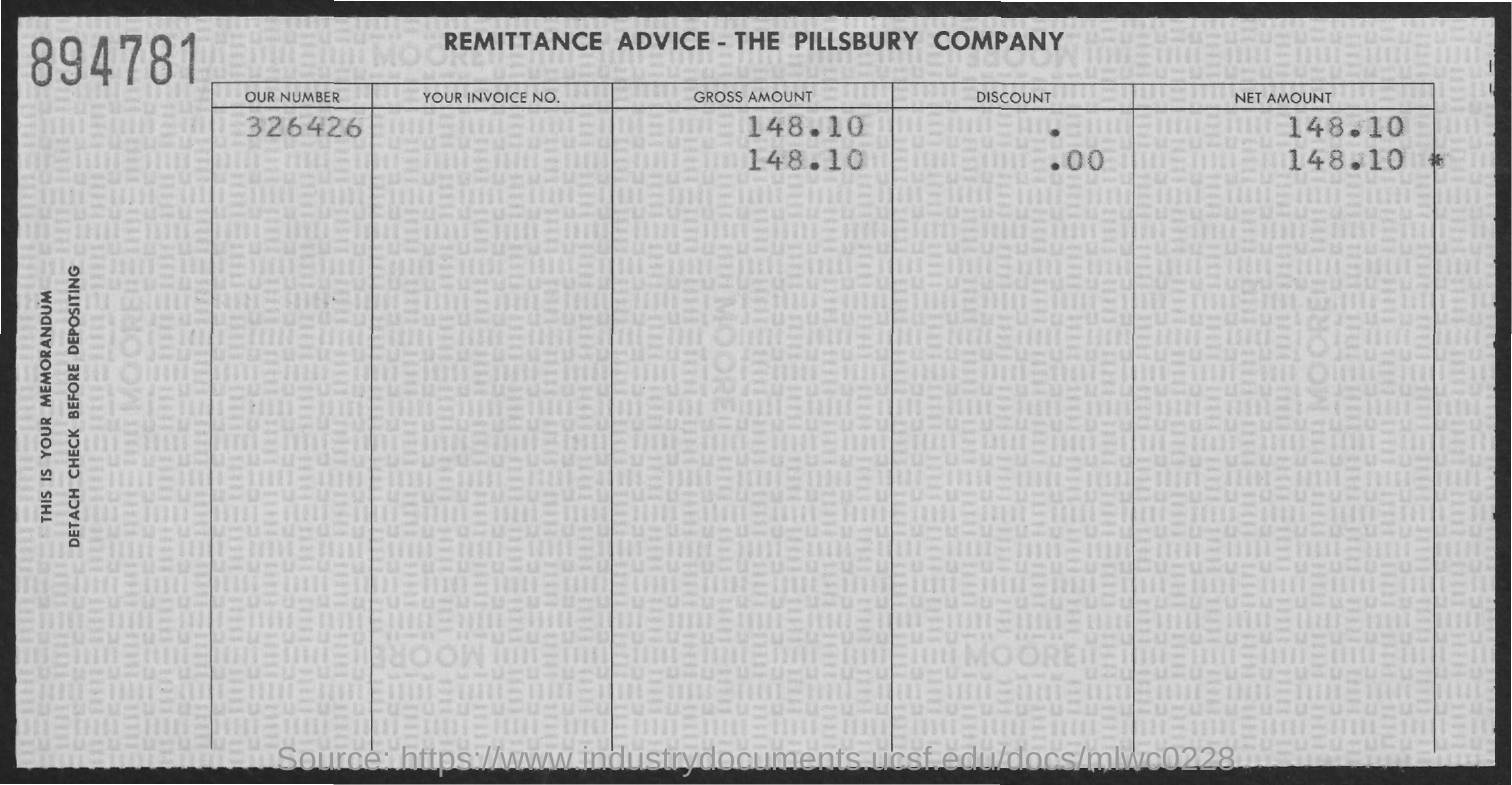Indicate a few pertinent items in this graphic. The remittance advice provided here belongs to the Pillsbury Company. The net amount mentioned in the remittance advice is 148 USD 10 cents. 